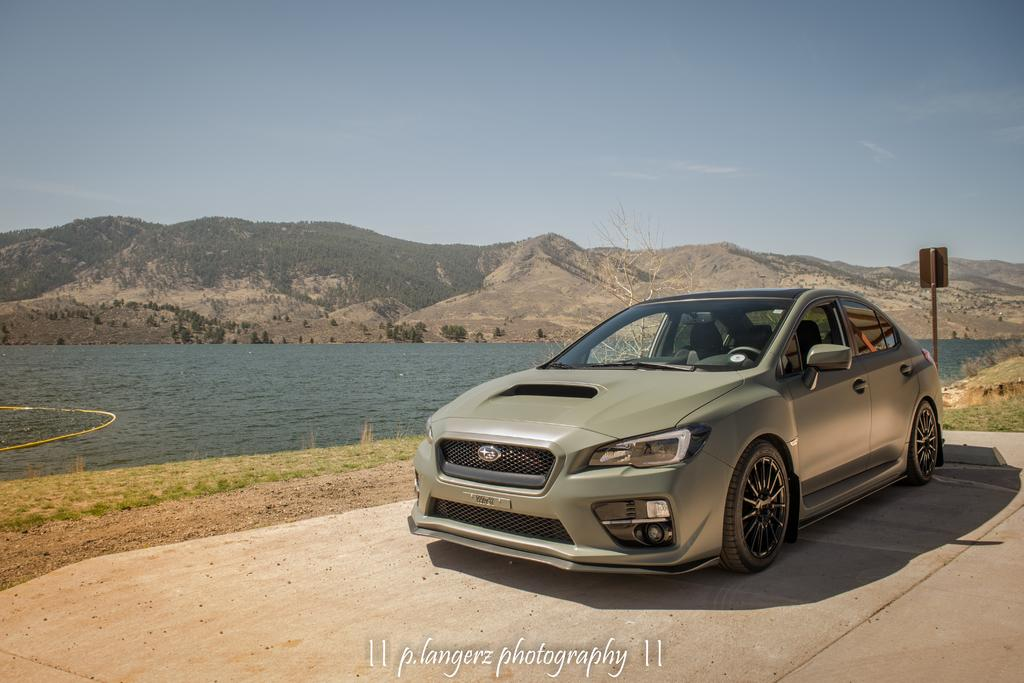What is the main subject of the image? There is a vehicle in the image. What is the setting of the image? The image features a road, a pole, a board, grassy ground, water, mountains, and a sky with clouds. Can you describe the road conditions in the image? The road is visible in the image. What is the weather like in the image? The sky with clouds is visible in the image, suggesting a partly cloudy day. What type of cheese is being served on the sofa during the vacation in the image? There is no cheese, sofa, or vacation present in the image. 